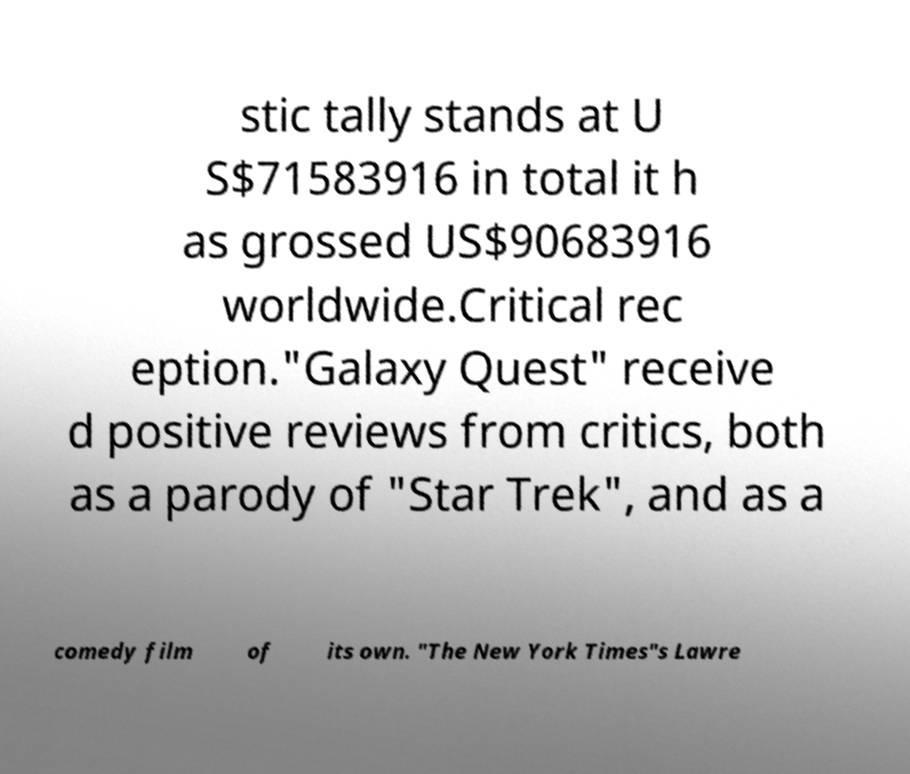Please identify and transcribe the text found in this image. stic tally stands at U S$71583916 in total it h as grossed US$90683916 worldwide.Critical rec eption."Galaxy Quest" receive d positive reviews from critics, both as a parody of "Star Trek", and as a comedy film of its own. "The New York Times"s Lawre 